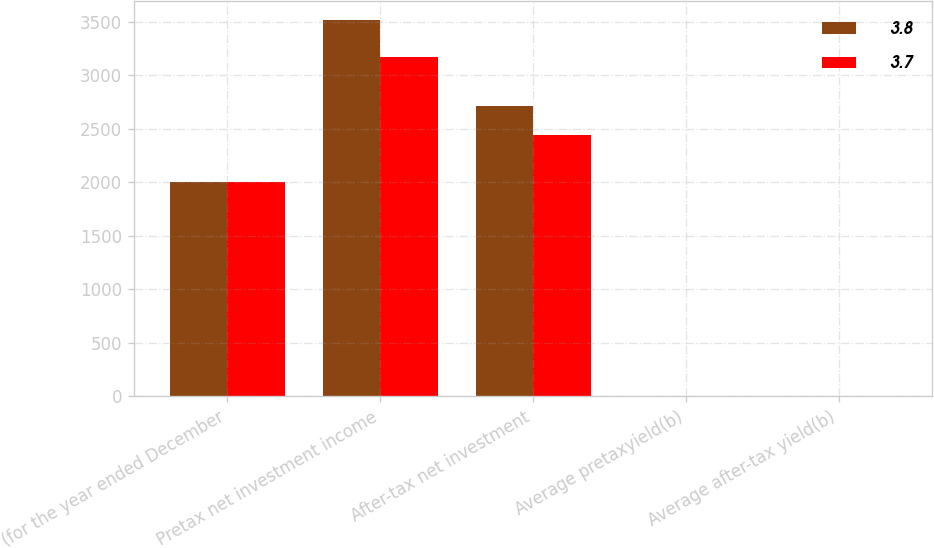Convert chart to OTSL. <chart><loc_0><loc_0><loc_500><loc_500><stacked_bar_chart><ecel><fcel>(for the year ended December<fcel>Pretax net investment income<fcel>After-tax net investment<fcel>Average pretaxyield(b)<fcel>Average after-tax yield(b)<nl><fcel>3.8<fcel>2006<fcel>3517<fcel>2712<fcel>4.9<fcel>3.8<nl><fcel>3.7<fcel>2005<fcel>3165<fcel>2438<fcel>4.7<fcel>3.7<nl></chart> 